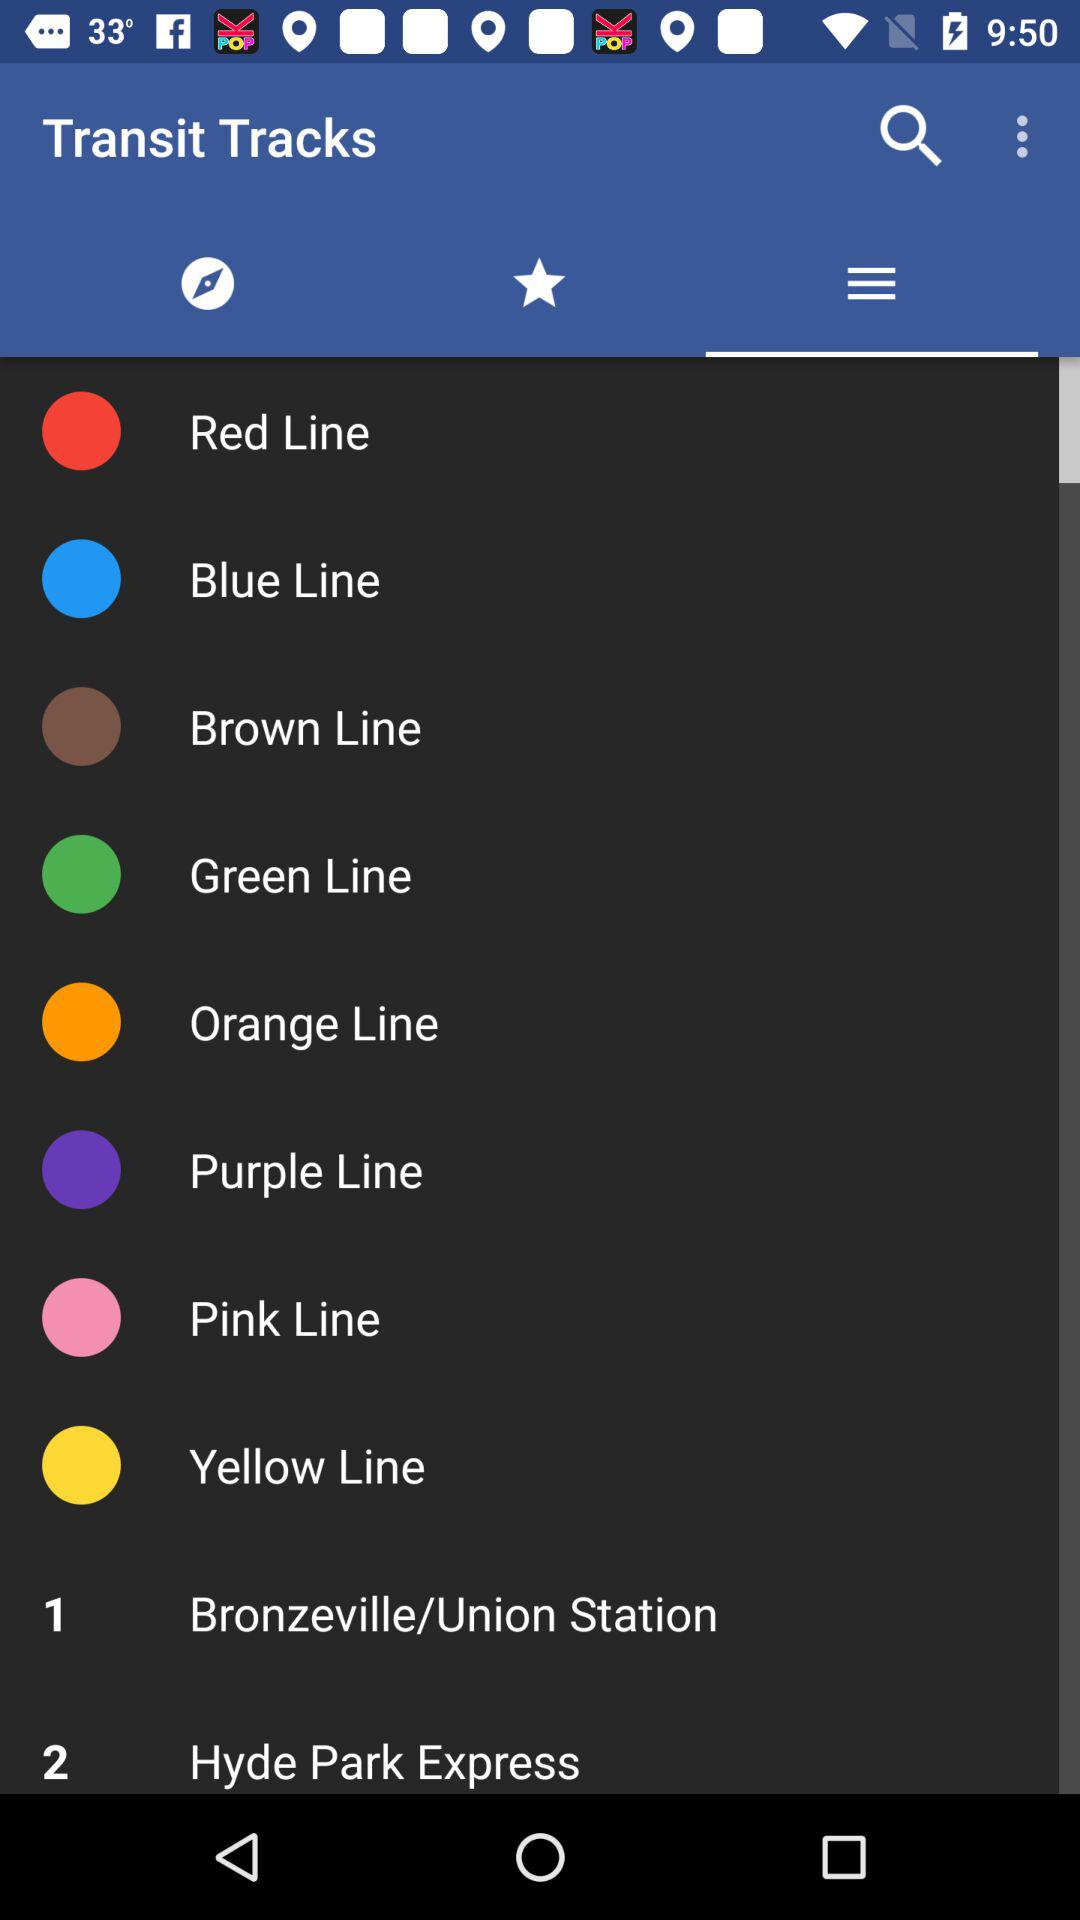Which tab is currently selected?
When the provided information is insufficient, respond with <no answer>. <no answer> 